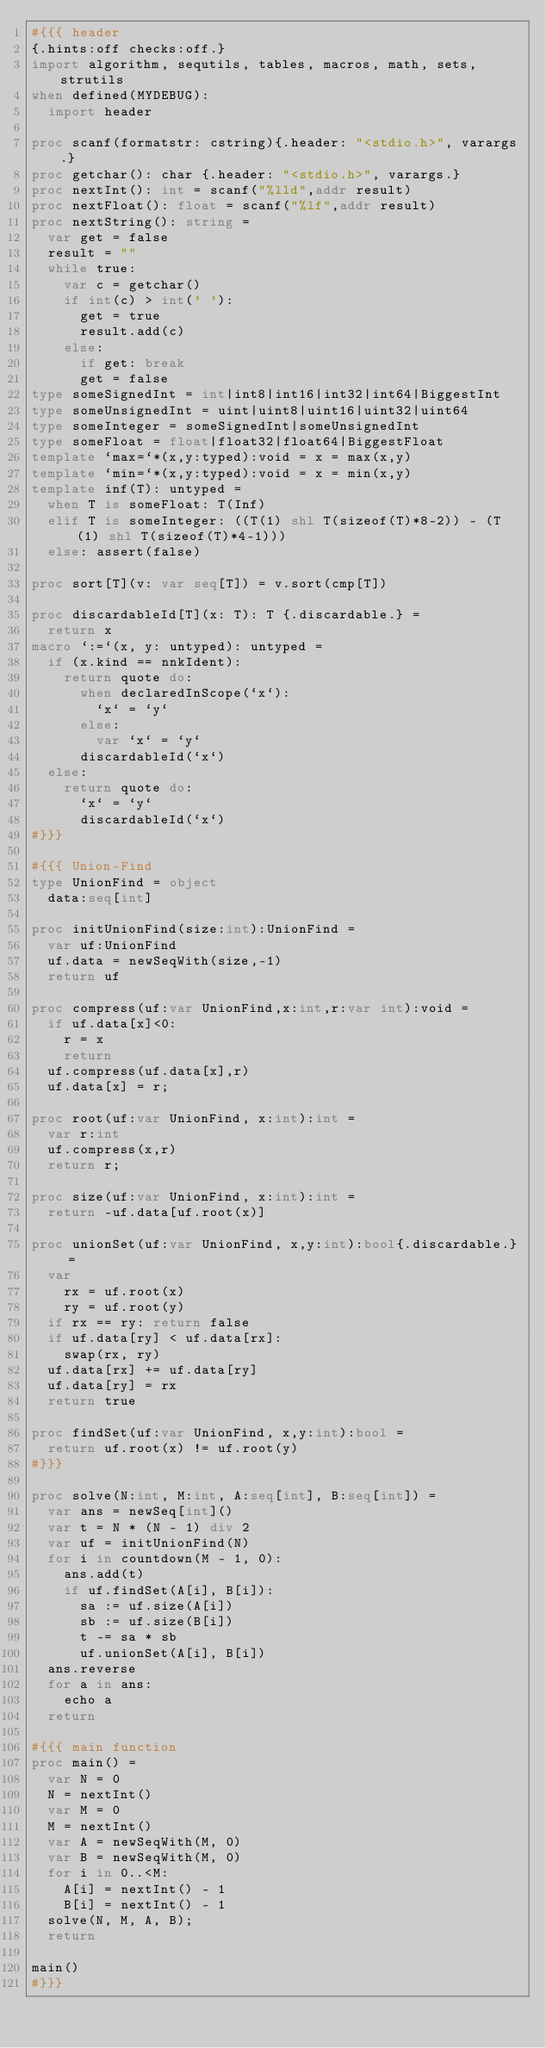<code> <loc_0><loc_0><loc_500><loc_500><_Nim_>#{{{ header
{.hints:off checks:off.}
import algorithm, sequtils, tables, macros, math, sets, strutils
when defined(MYDEBUG):
  import header

proc scanf(formatstr: cstring){.header: "<stdio.h>", varargs.}
proc getchar(): char {.header: "<stdio.h>", varargs.}
proc nextInt(): int = scanf("%lld",addr result)
proc nextFloat(): float = scanf("%lf",addr result)
proc nextString(): string =
  var get = false
  result = ""
  while true:
    var c = getchar()
    if int(c) > int(' '):
      get = true
      result.add(c)
    else:
      if get: break
      get = false
type someSignedInt = int|int8|int16|int32|int64|BiggestInt
type someUnsignedInt = uint|uint8|uint16|uint32|uint64
type someInteger = someSignedInt|someUnsignedInt
type someFloat = float|float32|float64|BiggestFloat
template `max=`*(x,y:typed):void = x = max(x,y)
template `min=`*(x,y:typed):void = x = min(x,y)
template inf(T): untyped = 
  when T is someFloat: T(Inf)
  elif T is someInteger: ((T(1) shl T(sizeof(T)*8-2)) - (T(1) shl T(sizeof(T)*4-1)))
  else: assert(false)

proc sort[T](v: var seq[T]) = v.sort(cmp[T])

proc discardableId[T](x: T): T {.discardable.} =
  return x
macro `:=`(x, y: untyped): untyped =
  if (x.kind == nnkIdent):
    return quote do:
      when declaredInScope(`x`):
        `x` = `y`
      else:
        var `x` = `y`
      discardableId(`x`)
  else:
    return quote do:
      `x` = `y`
      discardableId(`x`)
#}}}

#{{{ Union-Find
type UnionFind = object
  data:seq[int]

proc initUnionFind(size:int):UnionFind =
  var uf:UnionFind
  uf.data = newSeqWith(size,-1)
  return uf

proc compress(uf:var UnionFind,x:int,r:var int):void =
  if uf.data[x]<0:
    r = x
    return
  uf.compress(uf.data[x],r)
  uf.data[x] = r;

proc root(uf:var UnionFind, x:int):int =
  var r:int
  uf.compress(x,r)
  return r;

proc size(uf:var UnionFind, x:int):int =
  return -uf.data[uf.root(x)]

proc unionSet(uf:var UnionFind, x,y:int):bool{.discardable.} =
  var
    rx = uf.root(x)
    ry = uf.root(y)
  if rx == ry: return false
  if uf.data[ry] < uf.data[rx]:
    swap(rx, ry)
  uf.data[rx] += uf.data[ry]
  uf.data[ry] = rx
  return true

proc findSet(uf:var UnionFind, x,y:int):bool =
  return uf.root(x) != uf.root(y)
#}}}

proc solve(N:int, M:int, A:seq[int], B:seq[int]) =
  var ans = newSeq[int]()
  var t = N * (N - 1) div 2
  var uf = initUnionFind(N)
  for i in countdown(M - 1, 0):
    ans.add(t)
    if uf.findSet(A[i], B[i]):
      sa := uf.size(A[i])
      sb := uf.size(B[i])
      t -= sa * sb
      uf.unionSet(A[i], B[i])
  ans.reverse
  for a in ans:
    echo a
  return

#{{{ main function
proc main() =
  var N = 0
  N = nextInt()
  var M = 0
  M = nextInt()
  var A = newSeqWith(M, 0)
  var B = newSeqWith(M, 0)
  for i in 0..<M:
    A[i] = nextInt() - 1
    B[i] = nextInt() - 1
  solve(N, M, A, B);
  return

main()
#}}}
</code> 